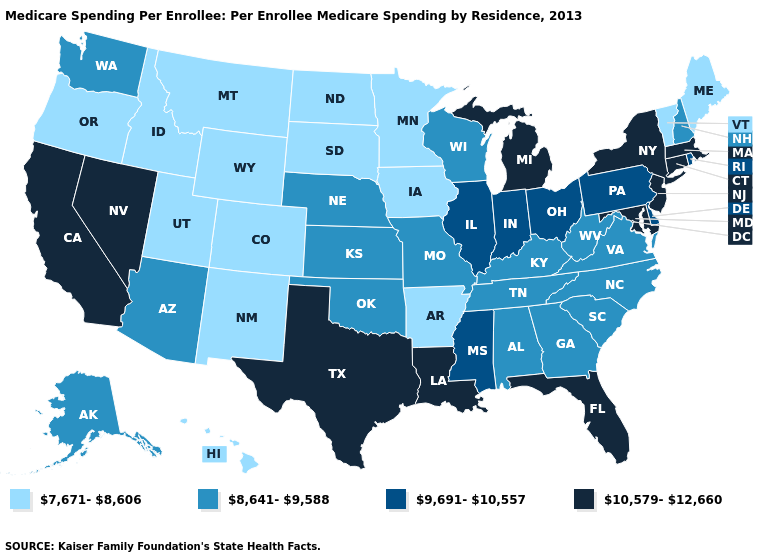Does New Mexico have the same value as Louisiana?
Give a very brief answer. No. What is the value of West Virginia?
Concise answer only. 8,641-9,588. Is the legend a continuous bar?
Quick response, please. No. Which states have the lowest value in the USA?
Write a very short answer. Arkansas, Colorado, Hawaii, Idaho, Iowa, Maine, Minnesota, Montana, New Mexico, North Dakota, Oregon, South Dakota, Utah, Vermont, Wyoming. What is the value of Tennessee?
Write a very short answer. 8,641-9,588. Which states have the lowest value in the USA?
Give a very brief answer. Arkansas, Colorado, Hawaii, Idaho, Iowa, Maine, Minnesota, Montana, New Mexico, North Dakota, Oregon, South Dakota, Utah, Vermont, Wyoming. Which states have the lowest value in the USA?
Write a very short answer. Arkansas, Colorado, Hawaii, Idaho, Iowa, Maine, Minnesota, Montana, New Mexico, North Dakota, Oregon, South Dakota, Utah, Vermont, Wyoming. Name the states that have a value in the range 7,671-8,606?
Keep it brief. Arkansas, Colorado, Hawaii, Idaho, Iowa, Maine, Minnesota, Montana, New Mexico, North Dakota, Oregon, South Dakota, Utah, Vermont, Wyoming. Is the legend a continuous bar?
Answer briefly. No. Name the states that have a value in the range 7,671-8,606?
Short answer required. Arkansas, Colorado, Hawaii, Idaho, Iowa, Maine, Minnesota, Montana, New Mexico, North Dakota, Oregon, South Dakota, Utah, Vermont, Wyoming. Name the states that have a value in the range 8,641-9,588?
Be succinct. Alabama, Alaska, Arizona, Georgia, Kansas, Kentucky, Missouri, Nebraska, New Hampshire, North Carolina, Oklahoma, South Carolina, Tennessee, Virginia, Washington, West Virginia, Wisconsin. What is the highest value in the USA?
Give a very brief answer. 10,579-12,660. Name the states that have a value in the range 8,641-9,588?
Give a very brief answer. Alabama, Alaska, Arizona, Georgia, Kansas, Kentucky, Missouri, Nebraska, New Hampshire, North Carolina, Oklahoma, South Carolina, Tennessee, Virginia, Washington, West Virginia, Wisconsin. Is the legend a continuous bar?
Write a very short answer. No. Does North Carolina have the highest value in the USA?
Give a very brief answer. No. 